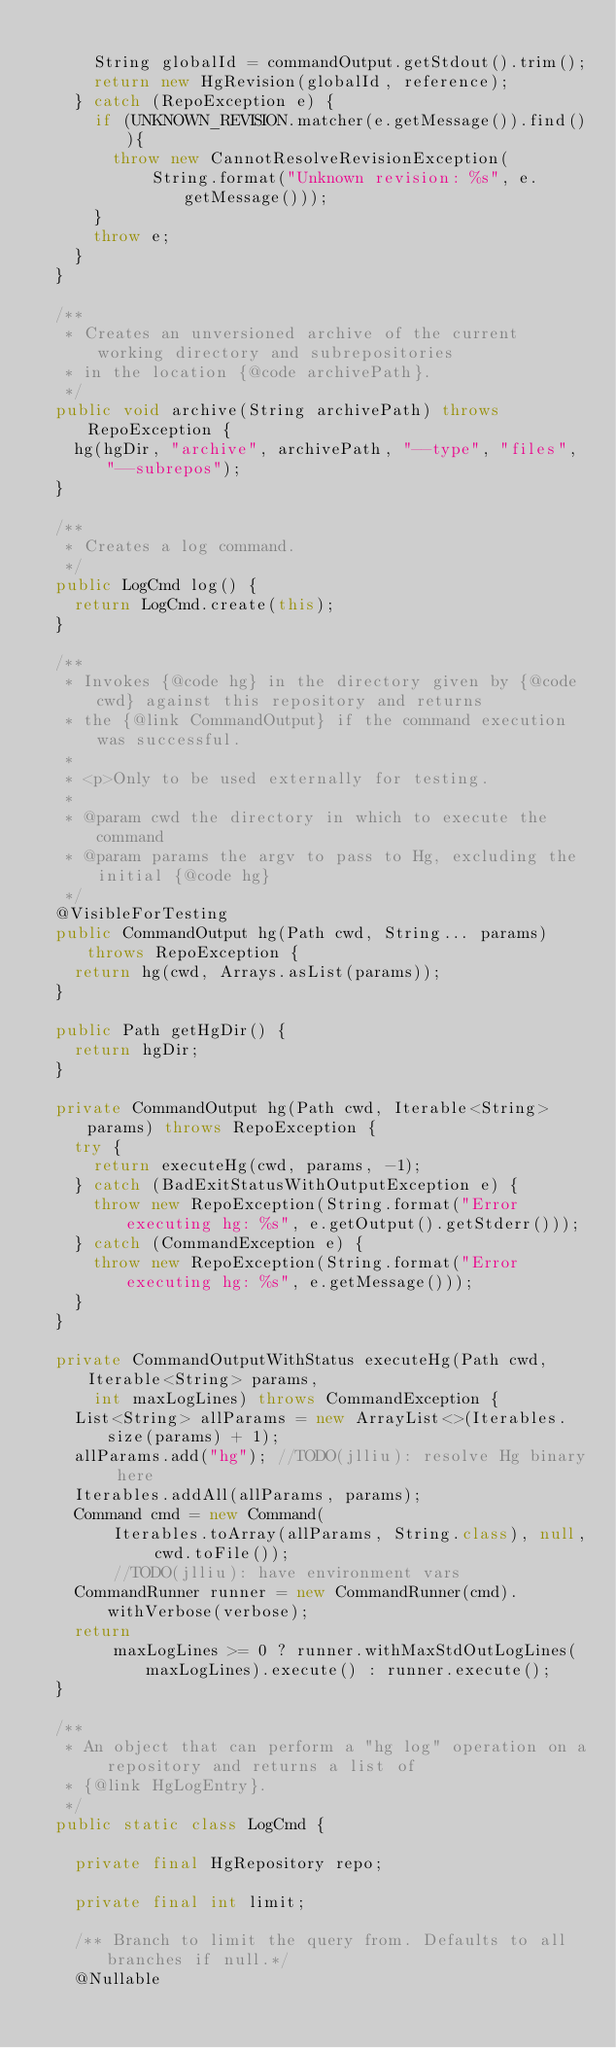Convert code to text. <code><loc_0><loc_0><loc_500><loc_500><_Java_>
      String globalId = commandOutput.getStdout().trim();
      return new HgRevision(globalId, reference);
    } catch (RepoException e) {
      if (UNKNOWN_REVISION.matcher(e.getMessage()).find()){
        throw new CannotResolveRevisionException(
            String.format("Unknown revision: %s", e.getMessage()));
      }
      throw e;
    }
  }

  /**
   * Creates an unversioned archive of the current working directory and subrepositories
   * in the location {@code archivePath}.
   */
  public void archive(String archivePath) throws RepoException {
    hg(hgDir, "archive", archivePath, "--type", "files", "--subrepos");
  }

  /**
   * Creates a log command.
   */
  public LogCmd log() {
    return LogCmd.create(this);
  }

  /**
   * Invokes {@code hg} in the directory given by {@code cwd} against this repository and returns
   * the {@link CommandOutput} if the command execution was successful.
   *
   * <p>Only to be used externally for testing.
   *
   * @param cwd the directory in which to execute the command
   * @param params the argv to pass to Hg, excluding the initial {@code hg}
   */
  @VisibleForTesting
  public CommandOutput hg(Path cwd, String... params) throws RepoException {
    return hg(cwd, Arrays.asList(params));
  }

  public Path getHgDir() {
    return hgDir;
  }

  private CommandOutput hg(Path cwd, Iterable<String> params) throws RepoException {
    try {
      return executeHg(cwd, params, -1);
    } catch (BadExitStatusWithOutputException e) {
      throw new RepoException(String.format("Error executing hg: %s", e.getOutput().getStderr()));
    } catch (CommandException e) {
      throw new RepoException(String.format("Error executing hg: %s", e.getMessage()));
    }
  }

  private CommandOutputWithStatus executeHg(Path cwd, Iterable<String> params,
      int maxLogLines) throws CommandException {
    List<String> allParams = new ArrayList<>(Iterables.size(params) + 1);
    allParams.add("hg"); //TODO(jlliu): resolve Hg binary here
    Iterables.addAll(allParams, params);
    Command cmd = new Command(
        Iterables.toArray(allParams, String.class), null, cwd.toFile());
        //TODO(jlliu): have environment vars
    CommandRunner runner = new CommandRunner(cmd).withVerbose(verbose);
    return
        maxLogLines >= 0 ? runner.withMaxStdOutLogLines(maxLogLines).execute() : runner.execute();
  }

  /**
   * An object that can perform a "hg log" operation on a repository and returns a list of
   * {@link HgLogEntry}.
   */
  public static class LogCmd {

    private final HgRepository repo;

    private final int limit;

    /** Branch to limit the query from. Defaults to all branches if null.*/
    @Nullable</code> 